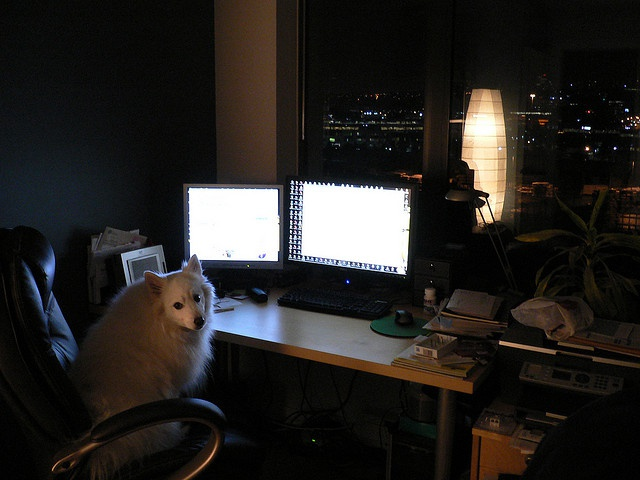Describe the objects in this image and their specific colors. I can see chair in black, navy, blue, and gray tones, dog in black, maroon, and gray tones, tv in black, white, navy, and gray tones, potted plant in black, maroon, and olive tones, and tv in black, white, gray, and navy tones in this image. 